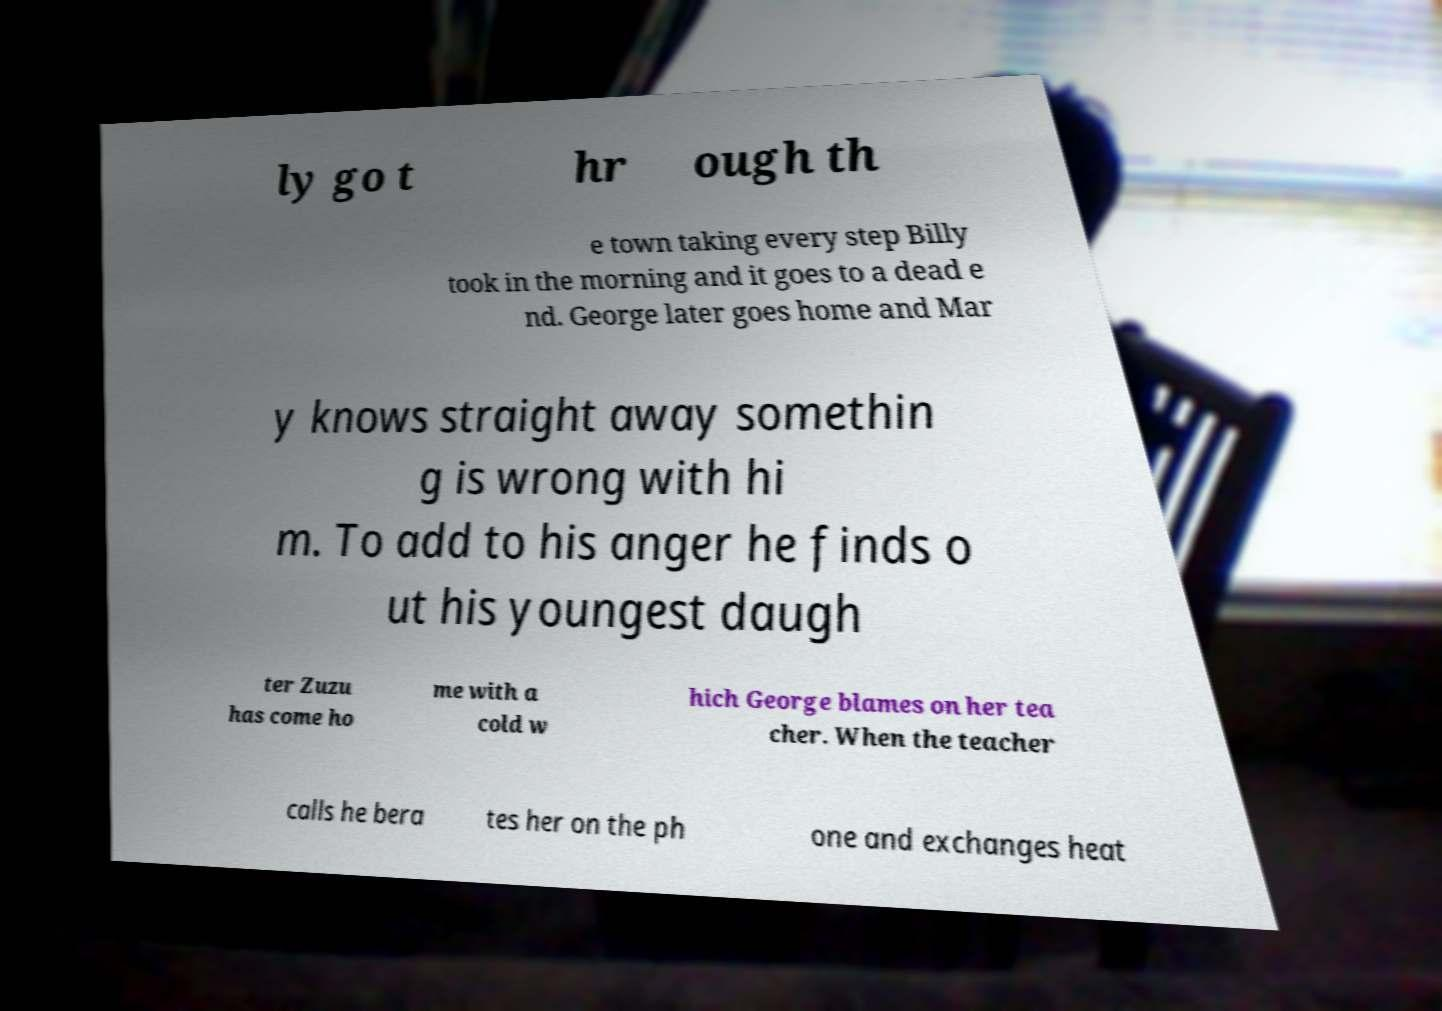I need the written content from this picture converted into text. Can you do that? ly go t hr ough th e town taking every step Billy took in the morning and it goes to a dead e nd. George later goes home and Mar y knows straight away somethin g is wrong with hi m. To add to his anger he finds o ut his youngest daugh ter Zuzu has come ho me with a cold w hich George blames on her tea cher. When the teacher calls he bera tes her on the ph one and exchanges heat 